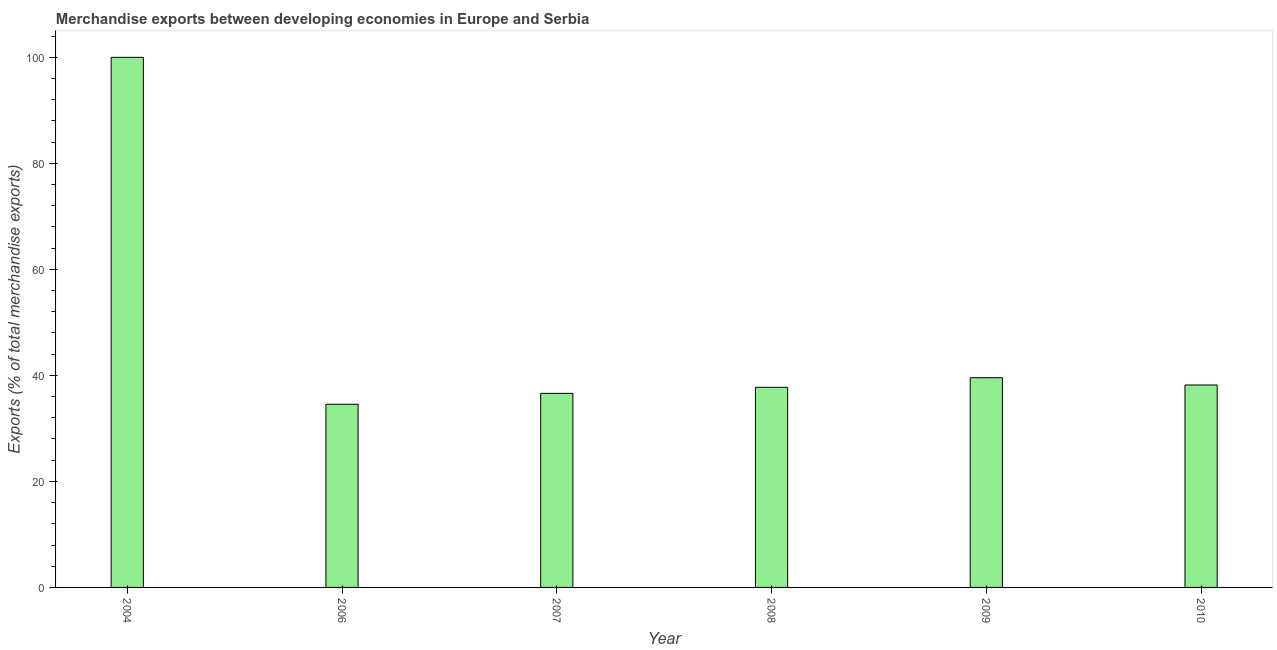What is the title of the graph?
Keep it short and to the point. Merchandise exports between developing economies in Europe and Serbia. What is the label or title of the Y-axis?
Provide a short and direct response. Exports (% of total merchandise exports). What is the merchandise exports in 2008?
Your response must be concise. 37.75. Across all years, what is the minimum merchandise exports?
Offer a very short reply. 34.56. In which year was the merchandise exports maximum?
Offer a terse response. 2004. What is the sum of the merchandise exports?
Provide a succinct answer. 286.67. What is the difference between the merchandise exports in 2009 and 2010?
Your response must be concise. 1.37. What is the average merchandise exports per year?
Provide a succinct answer. 47.78. What is the median merchandise exports?
Ensure brevity in your answer.  37.97. In how many years, is the merchandise exports greater than 20 %?
Give a very brief answer. 6. What is the ratio of the merchandise exports in 2007 to that in 2008?
Offer a very short reply. 0.97. Is the difference between the merchandise exports in 2004 and 2009 greater than the difference between any two years?
Provide a short and direct response. No. What is the difference between the highest and the second highest merchandise exports?
Ensure brevity in your answer.  60.44. Is the sum of the merchandise exports in 2008 and 2010 greater than the maximum merchandise exports across all years?
Your answer should be compact. No. What is the difference between the highest and the lowest merchandise exports?
Your answer should be very brief. 65.44. In how many years, is the merchandise exports greater than the average merchandise exports taken over all years?
Ensure brevity in your answer.  1. What is the difference between two consecutive major ticks on the Y-axis?
Keep it short and to the point. 20. Are the values on the major ticks of Y-axis written in scientific E-notation?
Your answer should be compact. No. What is the Exports (% of total merchandise exports) in 2006?
Provide a short and direct response. 34.56. What is the Exports (% of total merchandise exports) in 2007?
Your response must be concise. 36.61. What is the Exports (% of total merchandise exports) in 2008?
Offer a very short reply. 37.75. What is the Exports (% of total merchandise exports) in 2009?
Your answer should be compact. 39.56. What is the Exports (% of total merchandise exports) in 2010?
Keep it short and to the point. 38.19. What is the difference between the Exports (% of total merchandise exports) in 2004 and 2006?
Offer a very short reply. 65.44. What is the difference between the Exports (% of total merchandise exports) in 2004 and 2007?
Your answer should be compact. 63.39. What is the difference between the Exports (% of total merchandise exports) in 2004 and 2008?
Offer a very short reply. 62.25. What is the difference between the Exports (% of total merchandise exports) in 2004 and 2009?
Provide a short and direct response. 60.44. What is the difference between the Exports (% of total merchandise exports) in 2004 and 2010?
Offer a terse response. 61.81. What is the difference between the Exports (% of total merchandise exports) in 2006 and 2007?
Offer a terse response. -2.05. What is the difference between the Exports (% of total merchandise exports) in 2006 and 2008?
Offer a terse response. -3.2. What is the difference between the Exports (% of total merchandise exports) in 2006 and 2009?
Offer a terse response. -5.01. What is the difference between the Exports (% of total merchandise exports) in 2006 and 2010?
Make the answer very short. -3.64. What is the difference between the Exports (% of total merchandise exports) in 2007 and 2008?
Make the answer very short. -1.15. What is the difference between the Exports (% of total merchandise exports) in 2007 and 2009?
Make the answer very short. -2.96. What is the difference between the Exports (% of total merchandise exports) in 2007 and 2010?
Keep it short and to the point. -1.59. What is the difference between the Exports (% of total merchandise exports) in 2008 and 2009?
Keep it short and to the point. -1.81. What is the difference between the Exports (% of total merchandise exports) in 2008 and 2010?
Provide a short and direct response. -0.44. What is the difference between the Exports (% of total merchandise exports) in 2009 and 2010?
Offer a terse response. 1.37. What is the ratio of the Exports (% of total merchandise exports) in 2004 to that in 2006?
Offer a very short reply. 2.89. What is the ratio of the Exports (% of total merchandise exports) in 2004 to that in 2007?
Ensure brevity in your answer.  2.73. What is the ratio of the Exports (% of total merchandise exports) in 2004 to that in 2008?
Make the answer very short. 2.65. What is the ratio of the Exports (% of total merchandise exports) in 2004 to that in 2009?
Offer a very short reply. 2.53. What is the ratio of the Exports (% of total merchandise exports) in 2004 to that in 2010?
Give a very brief answer. 2.62. What is the ratio of the Exports (% of total merchandise exports) in 2006 to that in 2007?
Make the answer very short. 0.94. What is the ratio of the Exports (% of total merchandise exports) in 2006 to that in 2008?
Make the answer very short. 0.92. What is the ratio of the Exports (% of total merchandise exports) in 2006 to that in 2009?
Give a very brief answer. 0.87. What is the ratio of the Exports (% of total merchandise exports) in 2006 to that in 2010?
Make the answer very short. 0.91. What is the ratio of the Exports (% of total merchandise exports) in 2007 to that in 2009?
Your answer should be compact. 0.93. What is the ratio of the Exports (% of total merchandise exports) in 2007 to that in 2010?
Your answer should be compact. 0.96. What is the ratio of the Exports (% of total merchandise exports) in 2008 to that in 2009?
Provide a short and direct response. 0.95. What is the ratio of the Exports (% of total merchandise exports) in 2008 to that in 2010?
Provide a short and direct response. 0.99. What is the ratio of the Exports (% of total merchandise exports) in 2009 to that in 2010?
Provide a succinct answer. 1.04. 